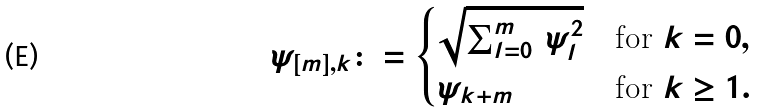Convert formula to latex. <formula><loc_0><loc_0><loc_500><loc_500>\psi _ { [ m ] , k } \colon = \begin{cases} \sqrt { \sum _ { l = 0 } ^ { m } \, \psi _ { l } ^ { 2 } } & \text {for $k=0$} , \\ \psi _ { k + m } & \text {for $k\geq 1$} . \end{cases}</formula> 